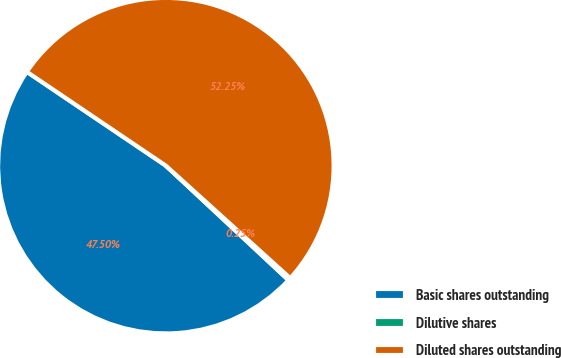<chart> <loc_0><loc_0><loc_500><loc_500><pie_chart><fcel>Basic shares outstanding<fcel>Dilutive shares<fcel>Diluted shares outstanding<nl><fcel>47.5%<fcel>0.25%<fcel>52.25%<nl></chart> 